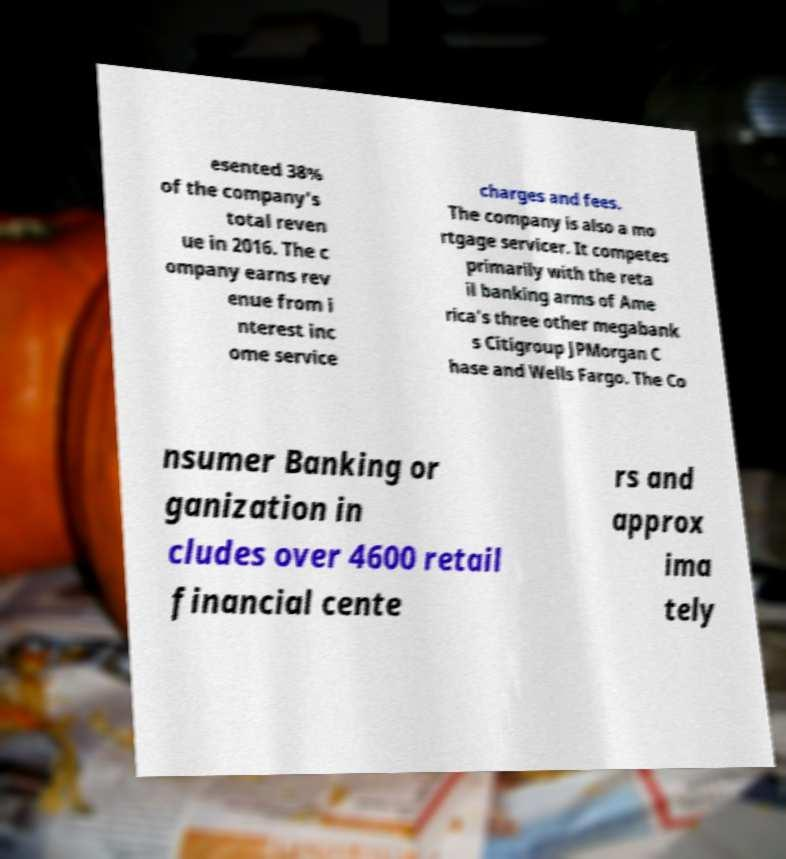What messages or text are displayed in this image? I need them in a readable, typed format. esented 38% of the company's total reven ue in 2016. The c ompany earns rev enue from i nterest inc ome service charges and fees. The company is also a mo rtgage servicer. It competes primarily with the reta il banking arms of Ame rica's three other megabank s Citigroup JPMorgan C hase and Wells Fargo. The Co nsumer Banking or ganization in cludes over 4600 retail financial cente rs and approx ima tely 